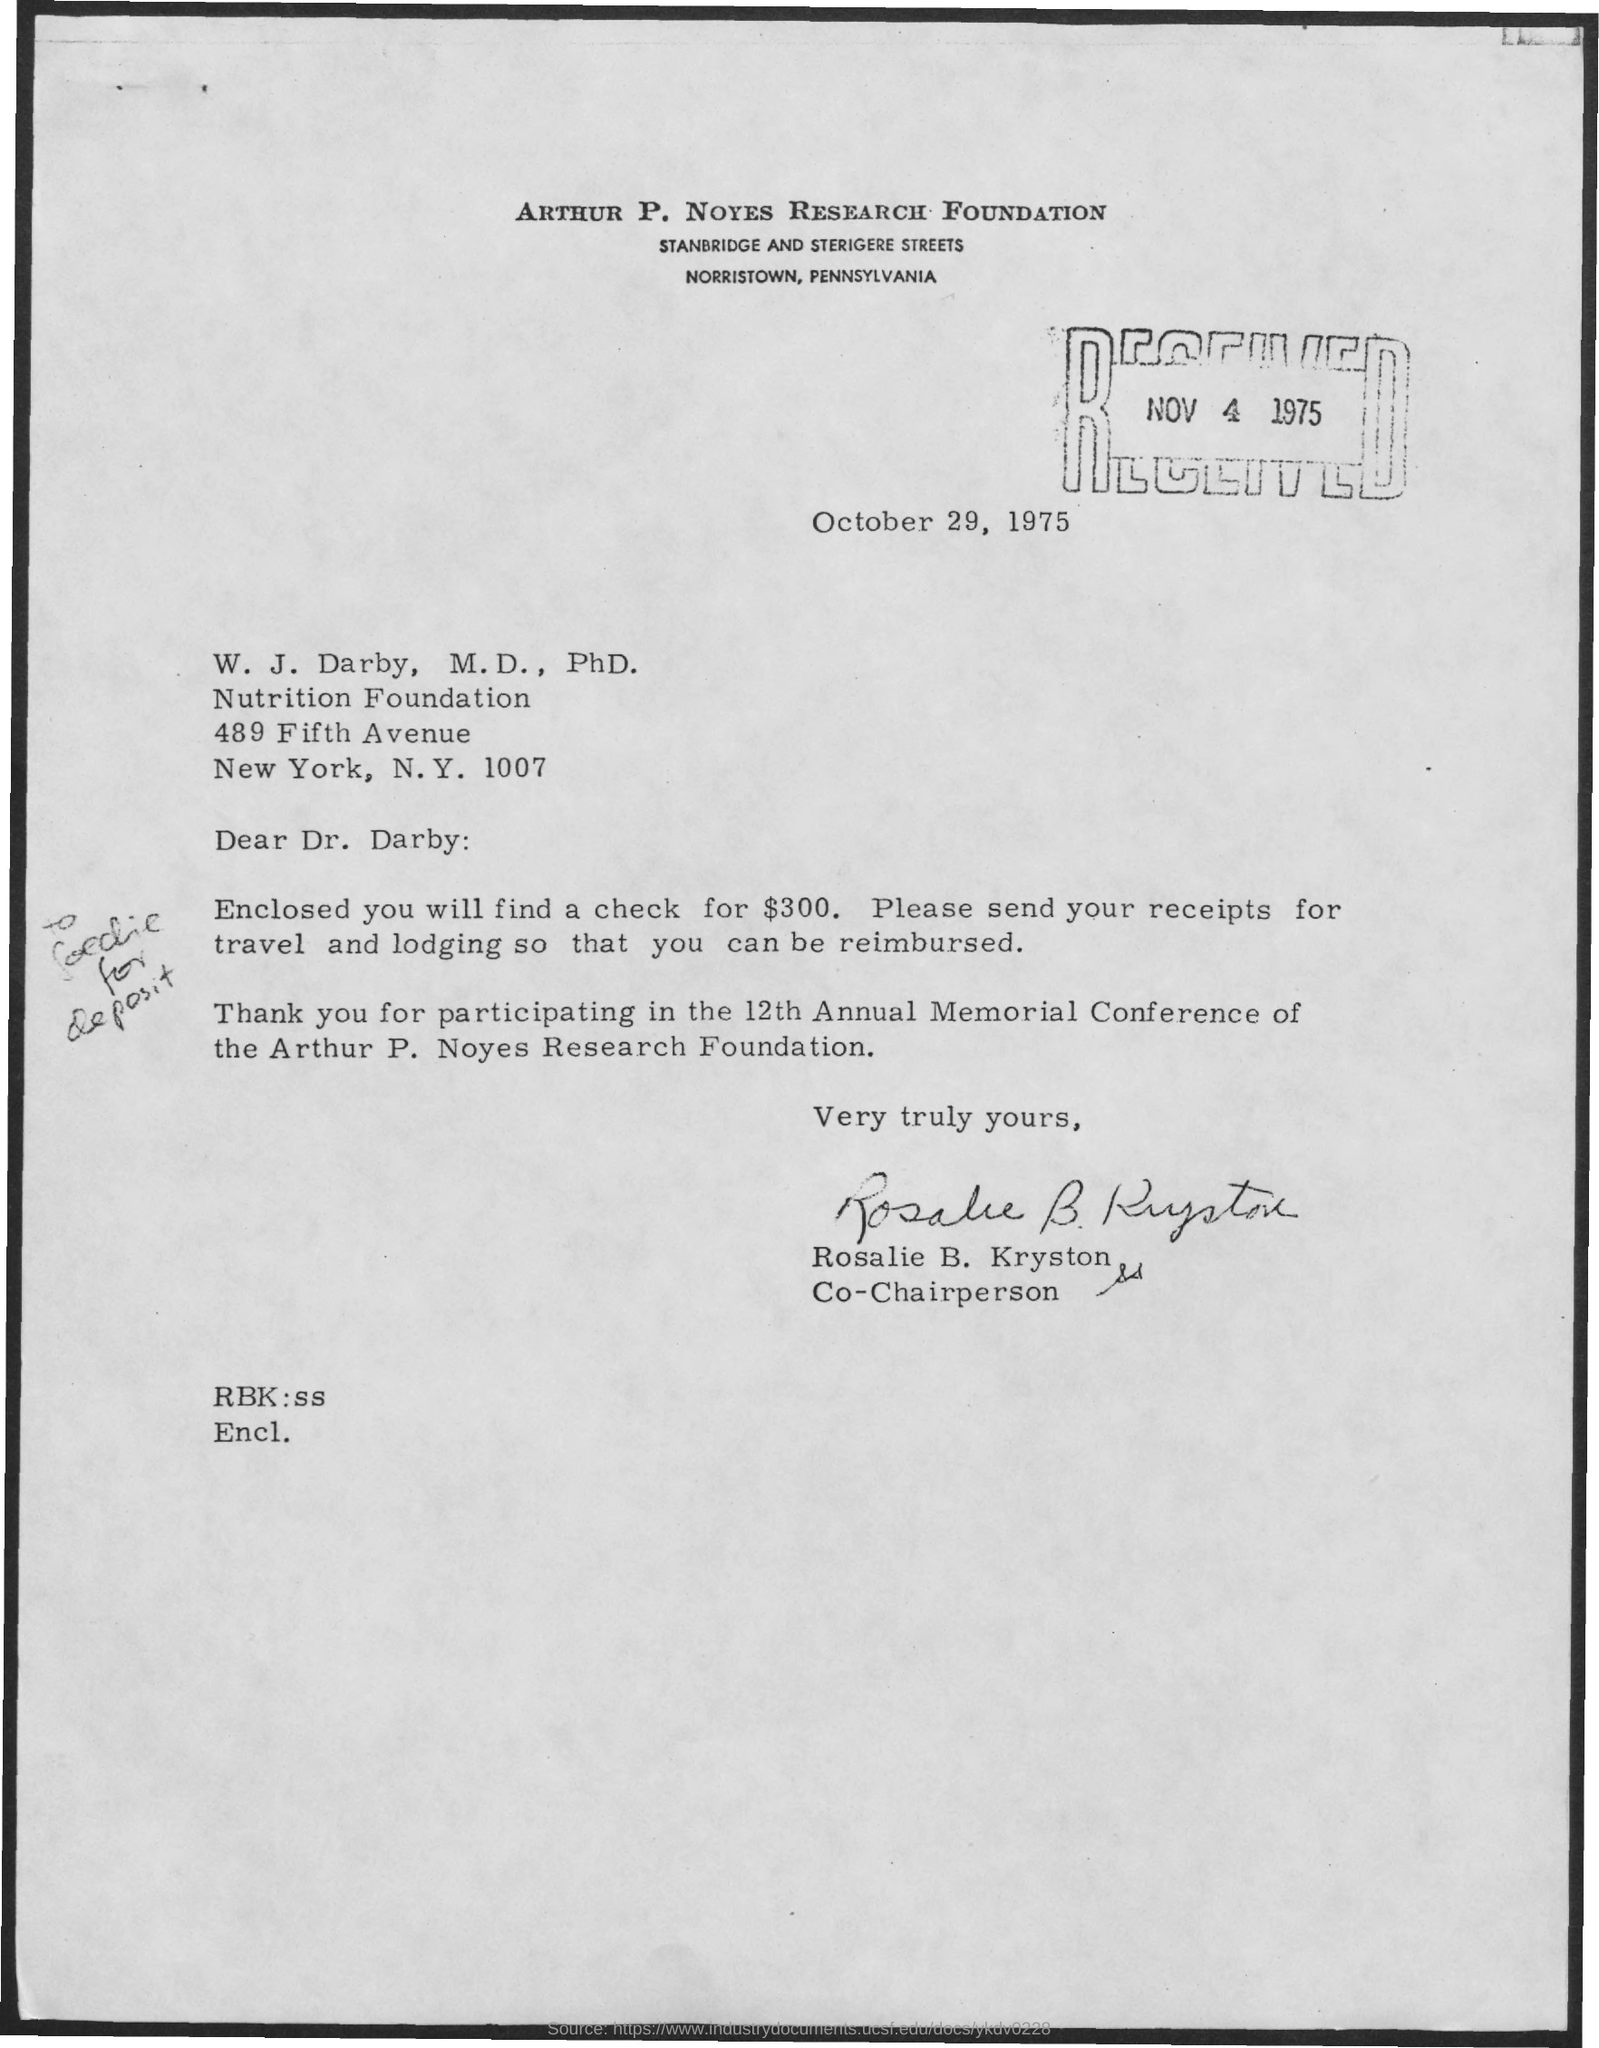Give some essential details in this illustration. The letter was written by Rosalie B. Kryston. Rosalie B. Kryston is the co-chairperson. The name of the Arthur P. Noyes Research Foundation is the ARTHUR P. NOYES RESEARCH FOUNDATION. The cheque enclosed with the letter is for $300. 